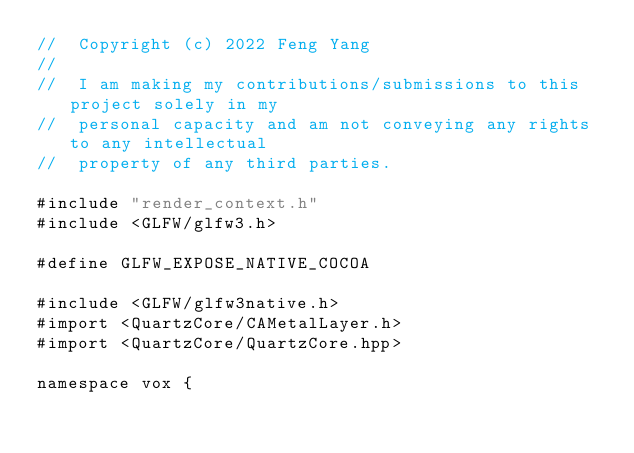<code> <loc_0><loc_0><loc_500><loc_500><_ObjectiveC_>//  Copyright (c) 2022 Feng Yang
//
//  I am making my contributions/submissions to this project solely in my
//  personal capacity and am not conveying any rights to any intellectual
//  property of any third parties.

#include "render_context.h"
#include <GLFW/glfw3.h>

#define GLFW_EXPOSE_NATIVE_COCOA

#include <GLFW/glfw3native.h>
#import <QuartzCore/CAMetalLayer.h>
#import <QuartzCore/QuartzCore.hpp>

namespace vox {</code> 